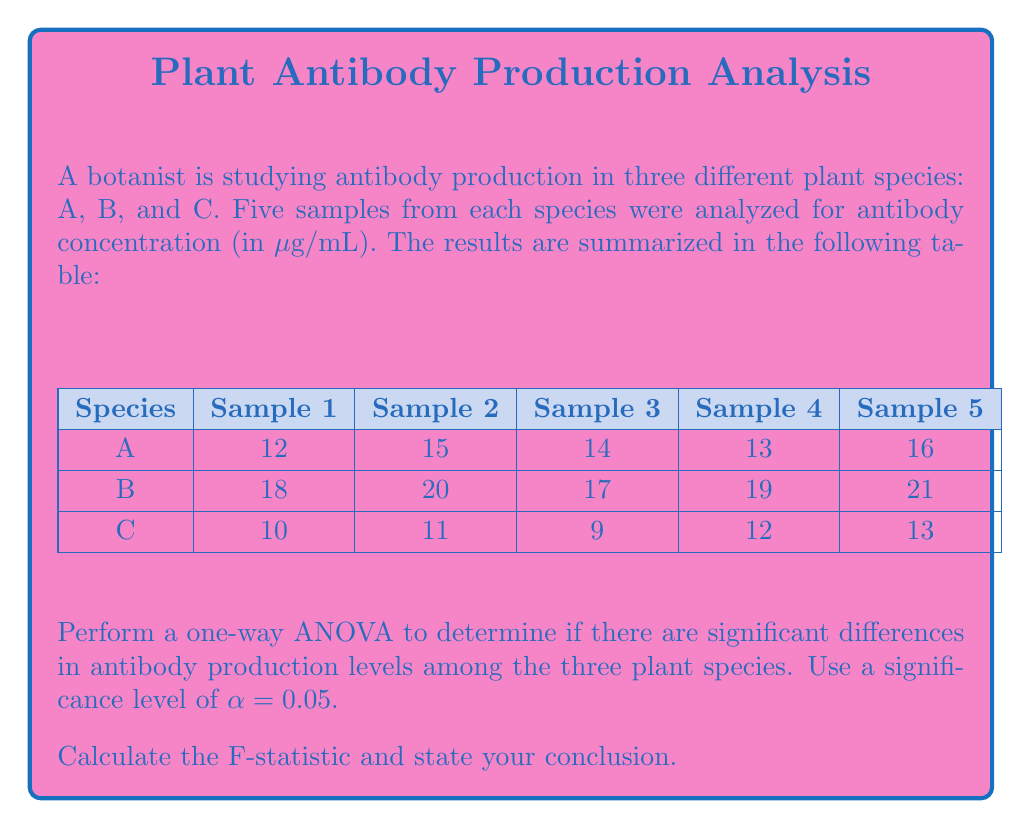Help me with this question. To perform a one-way ANOVA, we'll follow these steps:

1. Calculate the sum of squares (SS) for each group and the total:

   Species A: $\bar{x}_A = 14$, $SS_A = 10$
   Species B: $\bar{x}_B = 19$, $SS_B = 10$
   Species C: $\bar{x}_C = 11$, $SS_C = 10$

   Grand mean: $\bar{x} = 14.67$
   
   $SS_{total} = \sum(x - \bar{x})^2 = 228.67$
   $SS_{between} = n\sum(\bar{x}_i - \bar{x})^2 = 190$
   $SS_{within} = SS_A + SS_B + SS_C = 30$

2. Calculate degrees of freedom (df):
   
   $df_{between} = k - 1 = 2$ (where k is the number of groups)
   $df_{within} = N - k = 12$ (where N is the total number of samples)
   $df_{total} = N - 1 = 14$

3. Calculate mean squares (MS):

   $MS_{between} = \frac{SS_{between}}{df_{between}} = 95$
   $MS_{within} = \frac{SS_{within}}{df_{within}} = 2.5$

4. Calculate the F-statistic:

   $F = \frac{MS_{between}}{MS_{within}} = 38$

5. Find the critical F-value:

   $F_{crit}(2, 12) = 3.89$ at α = 0.05

6. Compare F-statistic to F-critical:

   Since $38 > 3.89$, we reject the null hypothesis.

Conclusion: There is significant evidence (F(2, 12) = 38, p < 0.05) to suggest that there are differences in antibody production levels among the three plant species.
Answer: F(2, 12) = 38, p < 0.05; Significant differences exist. 